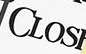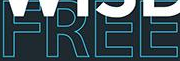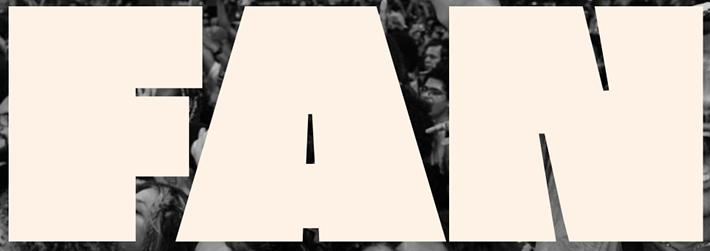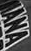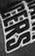Identify the words shown in these images in order, separated by a semicolon. CLOS; FREE; FAN; IANA; CERS 